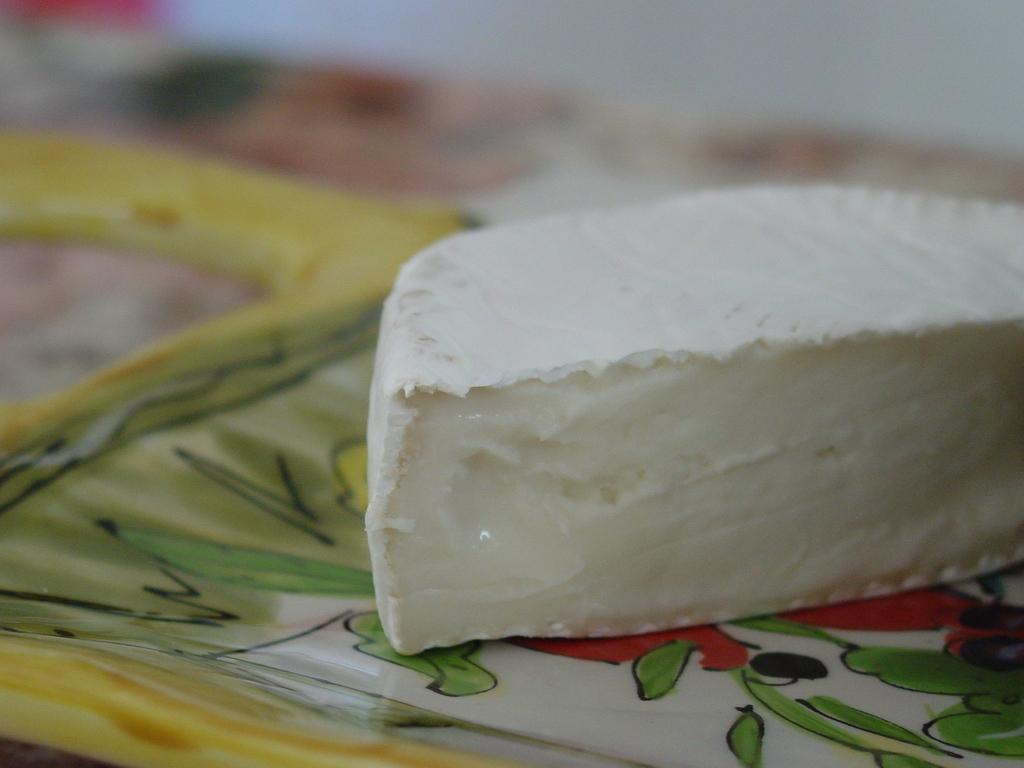What type of food is present in the image? There is cheese in the image. What color is the cheese? The cheese is white in color. How is the cheese presented in the image? The cheese is placed on a plate. Can you describe the background of the image? The background of the image is blurred. What type of birds can be seen flying in the image? There are no birds present in the image; it features cheese on a plate with a blurred background. What type of soda is being served with the cheese in the image? There is no soda present in the image; it only features cheese on a plate. 